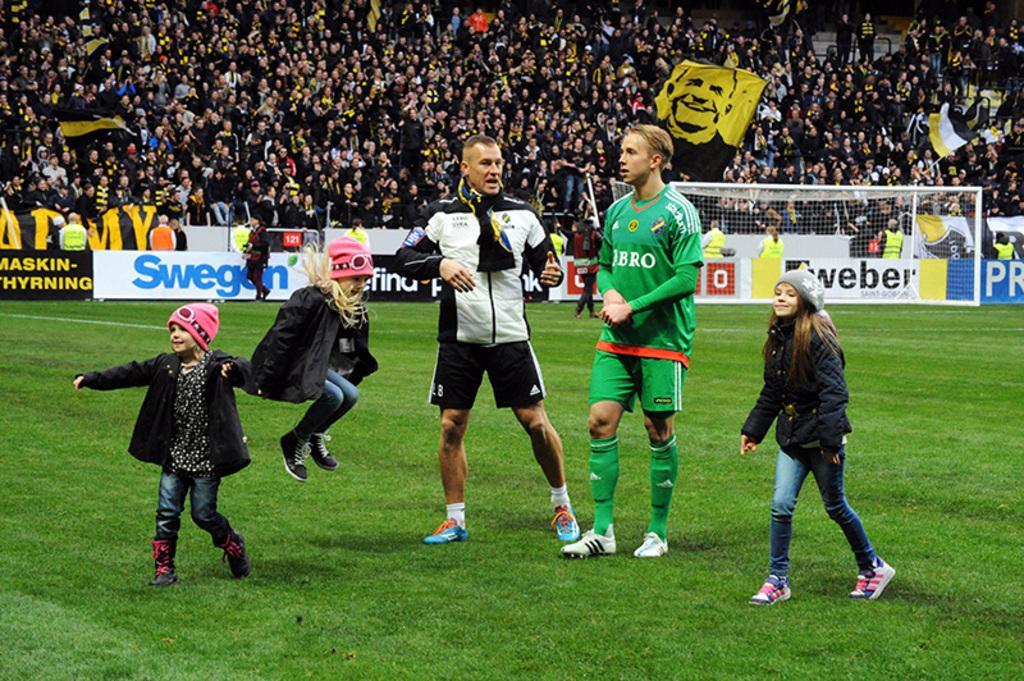Could you give a brief overview of what you see in this image? There are two men and two girls standing. Here is a girl jumping. I think this is a football ground. These are the hoardings. I can see the football goal post. There are groups of people standing. These look like the flags. 